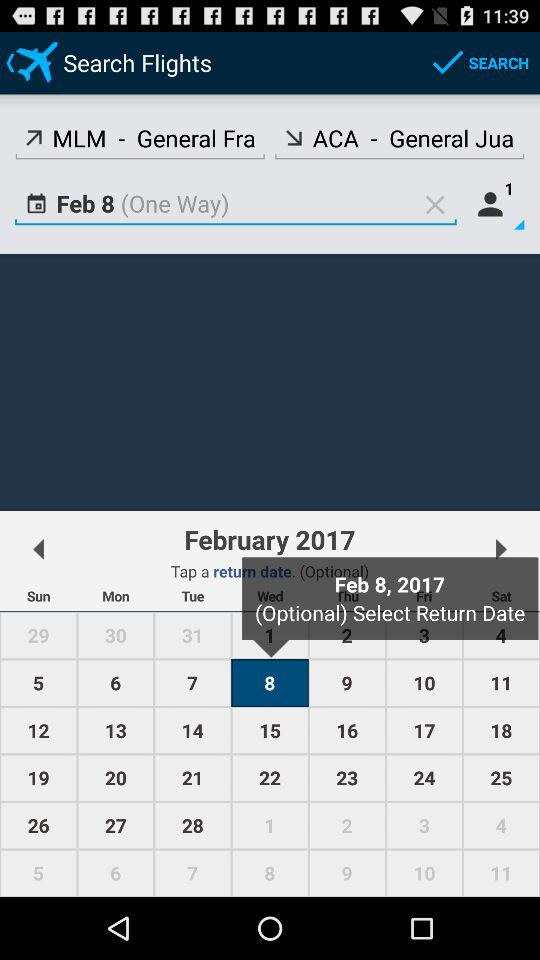How many people are included in this booking?
Answer the question using a single word or phrase. 1 